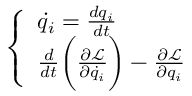<formula> <loc_0><loc_0><loc_500><loc_500>\left \{ \begin{array} { l l } { \dot { q } _ { i } = \frac { d q _ { i } } { d t } } \\ { \frac { d } { d t } \left ( \frac { \partial \mathcal { L } } { \partial \dot { q } _ { i } } \right ) - \frac { \partial \mathcal { L } } { \partial q _ { i } } } \end{array}</formula> 